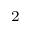Convert formula to latex. <formula><loc_0><loc_0><loc_500><loc_500>^ { 2 }</formula> 